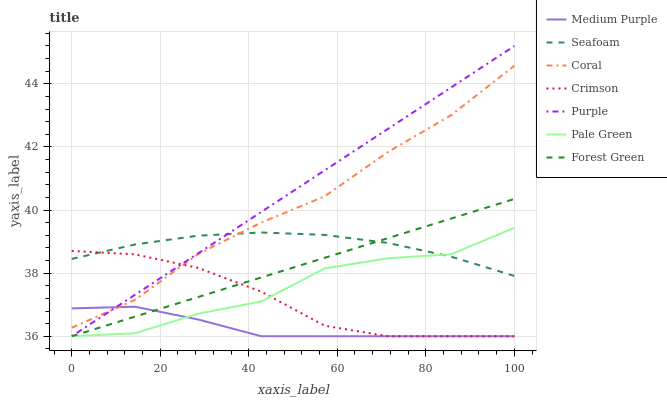Does Medium Purple have the minimum area under the curve?
Answer yes or no. Yes. Does Purple have the maximum area under the curve?
Answer yes or no. Yes. Does Coral have the minimum area under the curve?
Answer yes or no. No. Does Coral have the maximum area under the curve?
Answer yes or no. No. Is Purple the smoothest?
Answer yes or no. Yes. Is Pale Green the roughest?
Answer yes or no. Yes. Is Coral the smoothest?
Answer yes or no. No. Is Coral the roughest?
Answer yes or no. No. Does Purple have the lowest value?
Answer yes or no. Yes. Does Coral have the lowest value?
Answer yes or no. No. Does Purple have the highest value?
Answer yes or no. Yes. Does Coral have the highest value?
Answer yes or no. No. Is Pale Green less than Coral?
Answer yes or no. Yes. Is Coral greater than Pale Green?
Answer yes or no. Yes. Does Purple intersect Crimson?
Answer yes or no. Yes. Is Purple less than Crimson?
Answer yes or no. No. Is Purple greater than Crimson?
Answer yes or no. No. Does Pale Green intersect Coral?
Answer yes or no. No. 